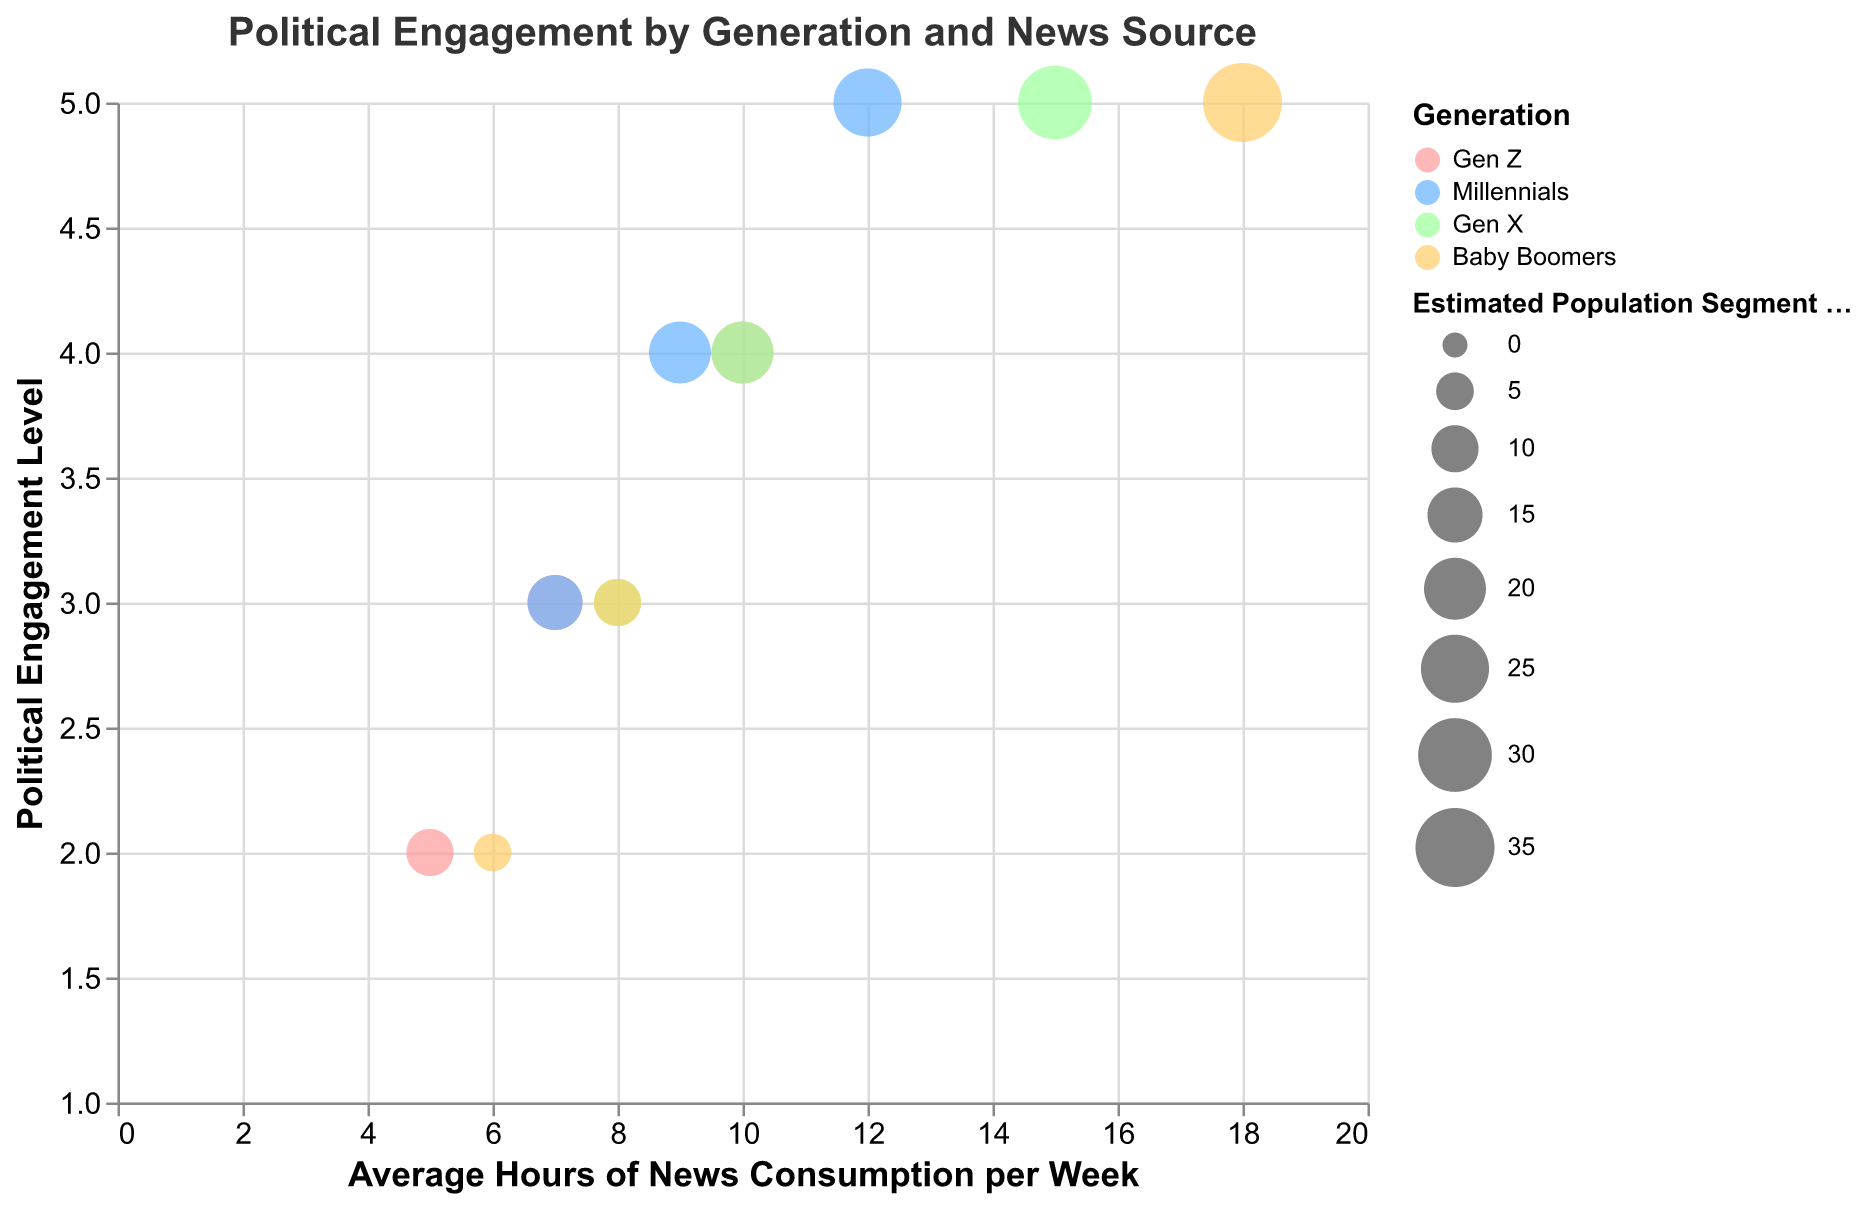What is the title of the figure? The title of the figure is displayed at the top and reads "Political Engagement by Generation and News Source."
Answer: Political Engagement by Generation and News Source How many generations are represented in the figure? The legend shows that there are four generations represented, with colors corresponding to each: Gen Z, Millennials, Gen X, and Baby Boomers.
Answer: Four Which generation has the highest political engagement level when their primary source of news is social media? By looking at the y-axis and identifying the shapes corresponding to different news sources colored by generation, "Millennials" using "Social Media" have the highest political engagement level, which is marked at a level of 5.
Answer: Millennials How many data points represent the Baby Boomers generation? By counting the number of bubbles color-coded for Baby Boomers (shown in a specific color in the legend), we see three bubbles corresponding to each news source: Social Media, Online News Websites, and Television.
Answer: Three What is the average hours of news consumption per week for Gen Z using social media? Locate the bubble for Gen Z using social media (circle). Refer to the x-axis representing "Average Hours of News Consumption per Week." The value for this bubble is 10 hours.
Answer: 10 hours Compare the political engagement levels between Gen X and Baby Boomers who primarily use television as their news source. Find the triangular bubble for both Gen X and Baby Boomers. Gen X has a political engagement level of 5, as does the Baby Boomers, when filtered by the y-axis. They both share the highest engagement level.
Answer: Equal Which generation has the largest estimated population segment size when their primary source of news is television? Look at the size of the triangular bubbles, as larger bubbles represent a larger population segment. The largest bubble is for the Baby Boomers generation.
Answer: Baby Boomers What's the difference in political engagement levels between Millennials using social media and Baby Boomers using online news websites? Locate the bubbles for Millennials using social media and Baby Boomers using online news websites. The political engagement levels are 5 and 3 respectively. The difference is 5 - 3 = 2.
Answer: 2 Which news source shows the highest average hours of news consumption for Gen X? Locate the three bubbles representing Gen X using different news sources and observe the x-axis values. The bubble representing television shows the highest consumption at 15 hours per week.
Answer: Television Which source of news shows the most frequent highest political engagement levels across all generations? By observing the highest points on the y-axis for bubbles with different shapes, television (triangular bubbles) consistently shows the highest engagement level of 5 across multiple generations.
Answer: Television 